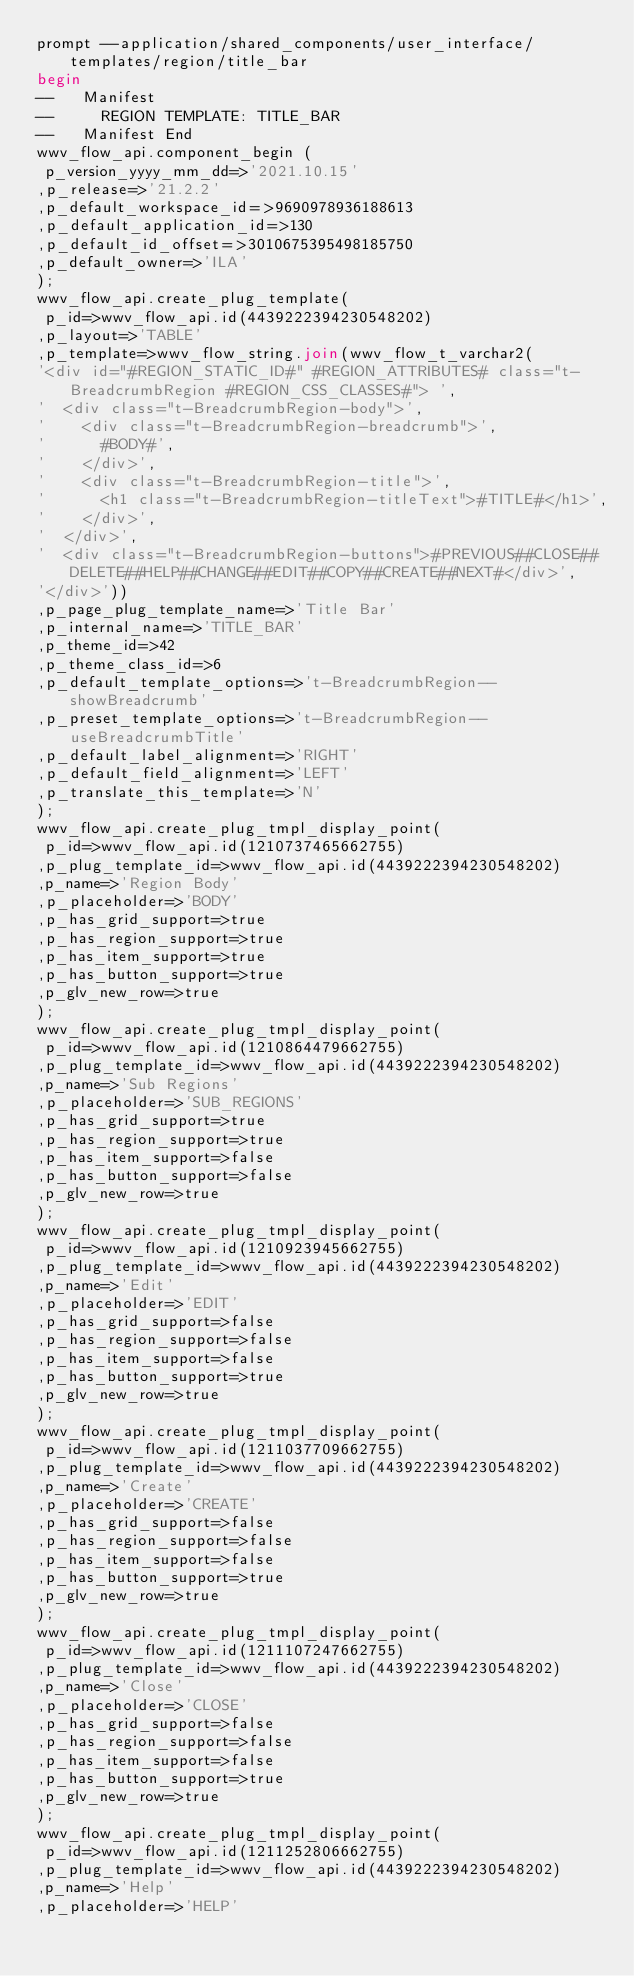<code> <loc_0><loc_0><loc_500><loc_500><_SQL_>prompt --application/shared_components/user_interface/templates/region/title_bar
begin
--   Manifest
--     REGION TEMPLATE: TITLE_BAR
--   Manifest End
wwv_flow_api.component_begin (
 p_version_yyyy_mm_dd=>'2021.10.15'
,p_release=>'21.2.2'
,p_default_workspace_id=>9690978936188613
,p_default_application_id=>130
,p_default_id_offset=>3010675395498185750
,p_default_owner=>'ILA'
);
wwv_flow_api.create_plug_template(
 p_id=>wwv_flow_api.id(4439222394230548202)
,p_layout=>'TABLE'
,p_template=>wwv_flow_string.join(wwv_flow_t_varchar2(
'<div id="#REGION_STATIC_ID#" #REGION_ATTRIBUTES# class="t-BreadcrumbRegion #REGION_CSS_CLASSES#"> ',
'  <div class="t-BreadcrumbRegion-body">',
'    <div class="t-BreadcrumbRegion-breadcrumb">',
'      #BODY#',
'    </div>',
'    <div class="t-BreadcrumbRegion-title">',
'      <h1 class="t-BreadcrumbRegion-titleText">#TITLE#</h1>',
'    </div>',
'  </div>',
'  <div class="t-BreadcrumbRegion-buttons">#PREVIOUS##CLOSE##DELETE##HELP##CHANGE##EDIT##COPY##CREATE##NEXT#</div>',
'</div>'))
,p_page_plug_template_name=>'Title Bar'
,p_internal_name=>'TITLE_BAR'
,p_theme_id=>42
,p_theme_class_id=>6
,p_default_template_options=>'t-BreadcrumbRegion--showBreadcrumb'
,p_preset_template_options=>'t-BreadcrumbRegion--useBreadcrumbTitle'
,p_default_label_alignment=>'RIGHT'
,p_default_field_alignment=>'LEFT'
,p_translate_this_template=>'N'
);
wwv_flow_api.create_plug_tmpl_display_point(
 p_id=>wwv_flow_api.id(1210737465662755)
,p_plug_template_id=>wwv_flow_api.id(4439222394230548202)
,p_name=>'Region Body'
,p_placeholder=>'BODY'
,p_has_grid_support=>true
,p_has_region_support=>true
,p_has_item_support=>true
,p_has_button_support=>true
,p_glv_new_row=>true
);
wwv_flow_api.create_plug_tmpl_display_point(
 p_id=>wwv_flow_api.id(1210864479662755)
,p_plug_template_id=>wwv_flow_api.id(4439222394230548202)
,p_name=>'Sub Regions'
,p_placeholder=>'SUB_REGIONS'
,p_has_grid_support=>true
,p_has_region_support=>true
,p_has_item_support=>false
,p_has_button_support=>false
,p_glv_new_row=>true
);
wwv_flow_api.create_plug_tmpl_display_point(
 p_id=>wwv_flow_api.id(1210923945662755)
,p_plug_template_id=>wwv_flow_api.id(4439222394230548202)
,p_name=>'Edit'
,p_placeholder=>'EDIT'
,p_has_grid_support=>false
,p_has_region_support=>false
,p_has_item_support=>false
,p_has_button_support=>true
,p_glv_new_row=>true
);
wwv_flow_api.create_plug_tmpl_display_point(
 p_id=>wwv_flow_api.id(1211037709662755)
,p_plug_template_id=>wwv_flow_api.id(4439222394230548202)
,p_name=>'Create'
,p_placeholder=>'CREATE'
,p_has_grid_support=>false
,p_has_region_support=>false
,p_has_item_support=>false
,p_has_button_support=>true
,p_glv_new_row=>true
);
wwv_flow_api.create_plug_tmpl_display_point(
 p_id=>wwv_flow_api.id(1211107247662755)
,p_plug_template_id=>wwv_flow_api.id(4439222394230548202)
,p_name=>'Close'
,p_placeholder=>'CLOSE'
,p_has_grid_support=>false
,p_has_region_support=>false
,p_has_item_support=>false
,p_has_button_support=>true
,p_glv_new_row=>true
);
wwv_flow_api.create_plug_tmpl_display_point(
 p_id=>wwv_flow_api.id(1211252806662755)
,p_plug_template_id=>wwv_flow_api.id(4439222394230548202)
,p_name=>'Help'
,p_placeholder=>'HELP'</code> 